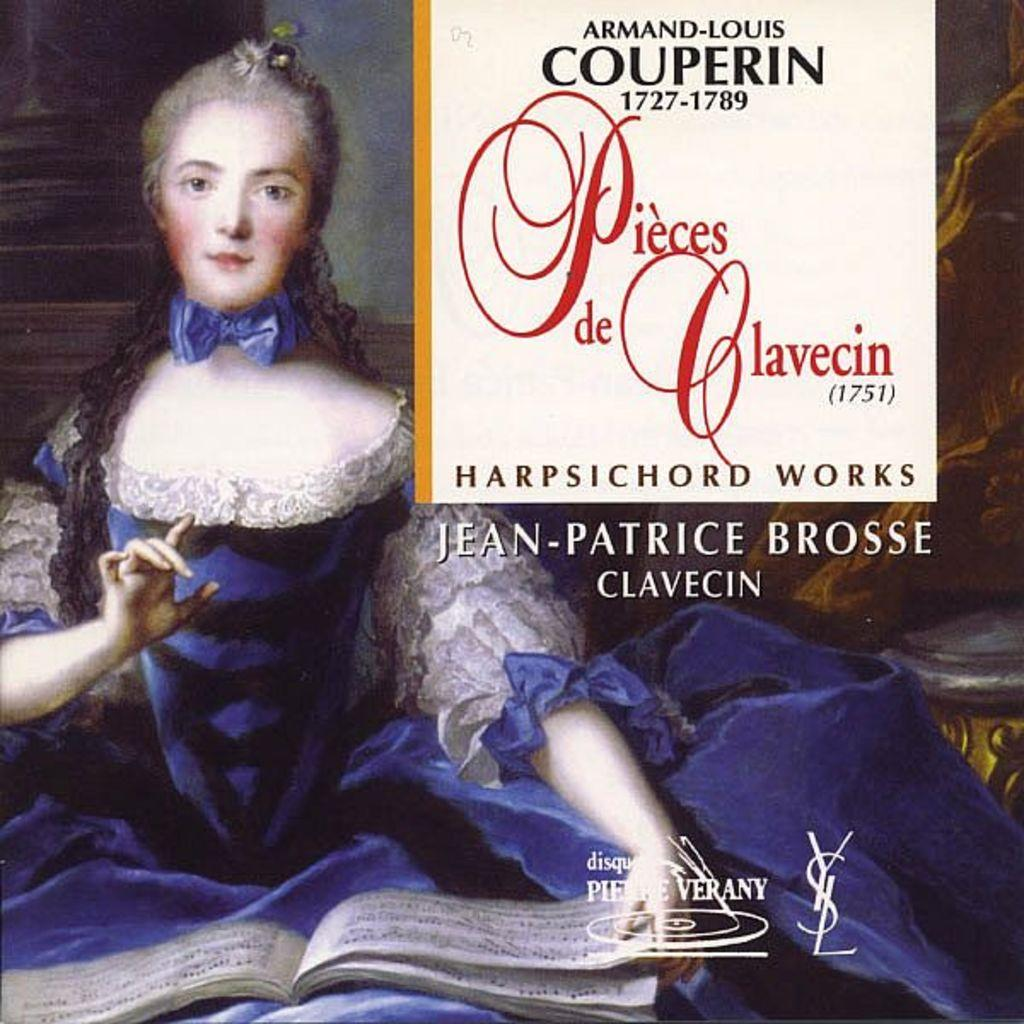<image>
Give a short and clear explanation of the subsequent image. Cover for "Pieces de Glavecin" showing a woman wearing a white and blue dress on the cover. 